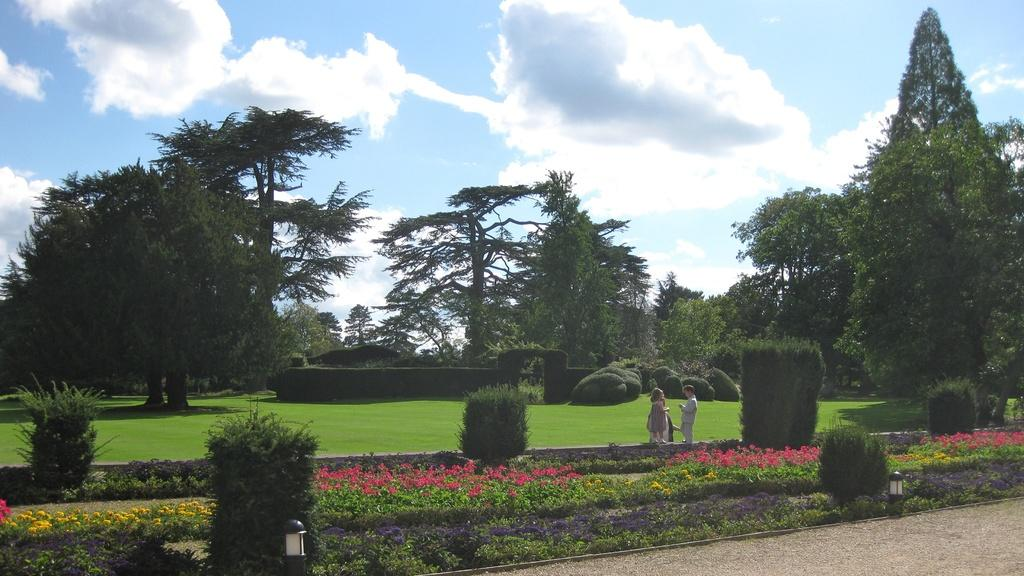What type of plants can be seen in the image? There are flowers in the image. How many people are present in the image? There are two people standing in the image. What can be seen in the background of the image? There is grass, trees, and clouds visible in the sky in the background of the image. What type of grain is being harvested by the cars in the image? There are no cars or grain present in the image; it features flowers, two people, grass, trees, and clouds. 